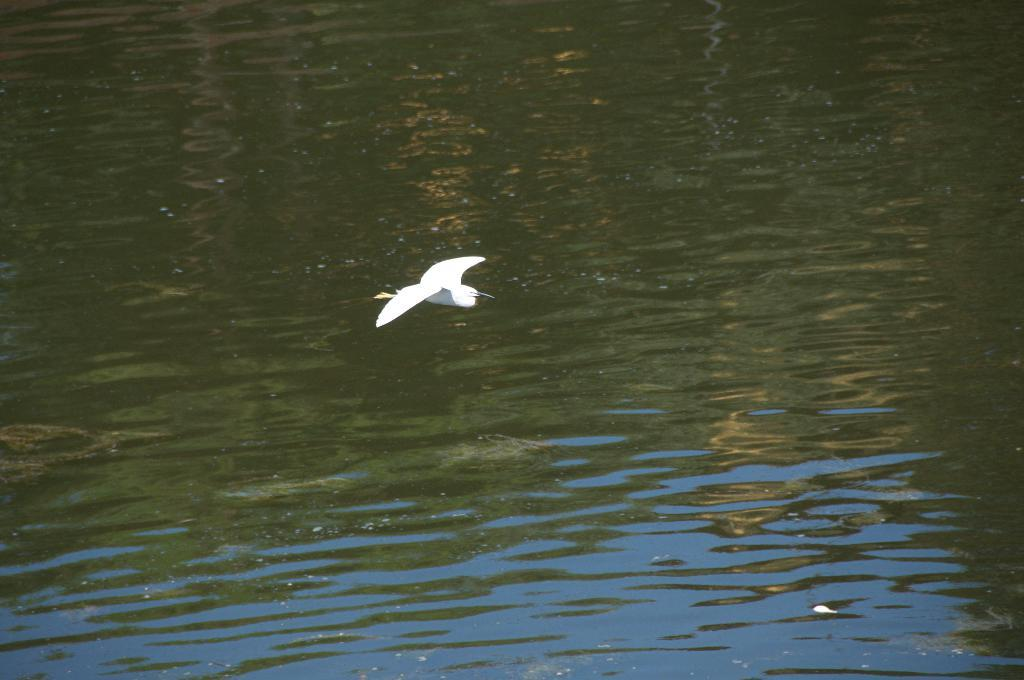What type of animal can be seen in the image? There is a white color bird in the image. What is the bird doing in the image? The bird is flying in the air. What can be seen in the background of the image? There is water visible in the background of the image. What type of property does the bird own in the image? There is no information about the bird owning any property in the image. Can you describe the visitor that the bird is interacting with in the image? There are no visitors present in the image; it only features the bird flying in the air. 